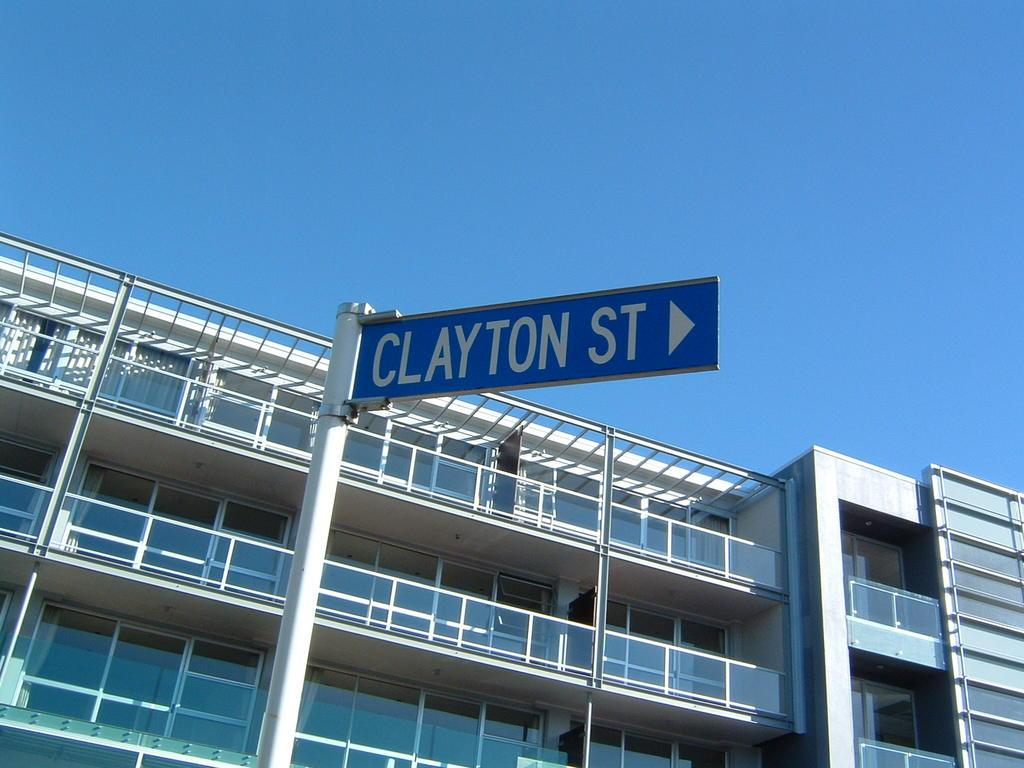What type of structure can be seen in the image? There is a building in the image. What else is present in the image besides the building? There is a board attached to a pole in the image. What is written on the board? The board has some text on it. What is the color of the sky in the image? The sky is blue in the image. How does the square root of the building affect the brain in the image? There is no mention of a square root or the brain in the image; it only features a building and a board with text. 